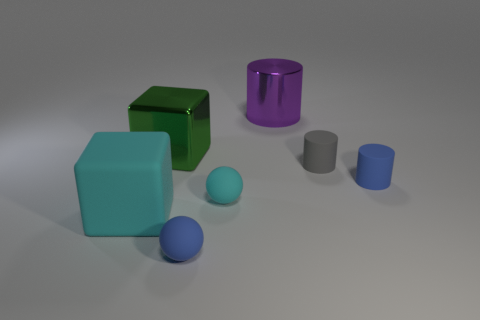What is the material of the purple cylinder?
Your answer should be very brief. Metal. There is a small gray rubber cylinder; are there any gray matte cylinders in front of it?
Make the answer very short. No. Is the large rubber object the same shape as the green thing?
Provide a succinct answer. Yes. What number of other objects are the same size as the cyan ball?
Ensure brevity in your answer.  3. What number of things are either cubes that are on the left side of the small cyan thing or small cyan matte things?
Ensure brevity in your answer.  3. The big matte object has what color?
Make the answer very short. Cyan. What material is the big object that is behind the shiny block?
Keep it short and to the point. Metal. Do the tiny cyan rubber thing and the small blue matte object behind the cyan rubber block have the same shape?
Your response must be concise. No. Is the number of cyan rubber things greater than the number of things?
Make the answer very short. No. Are there any other things that have the same color as the big rubber block?
Provide a succinct answer. Yes. 